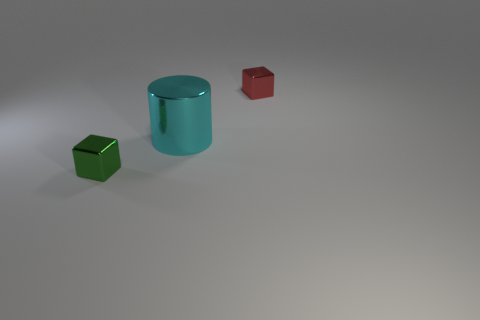Add 2 large cyan cylinders. How many objects exist? 5 Subtract all cylinders. How many objects are left? 2 Subtract all big brown matte spheres. Subtract all big things. How many objects are left? 2 Add 2 tiny green metallic blocks. How many tiny green metallic blocks are left? 3 Add 3 big purple metallic cubes. How many big purple metallic cubes exist? 3 Subtract 0 gray blocks. How many objects are left? 3 